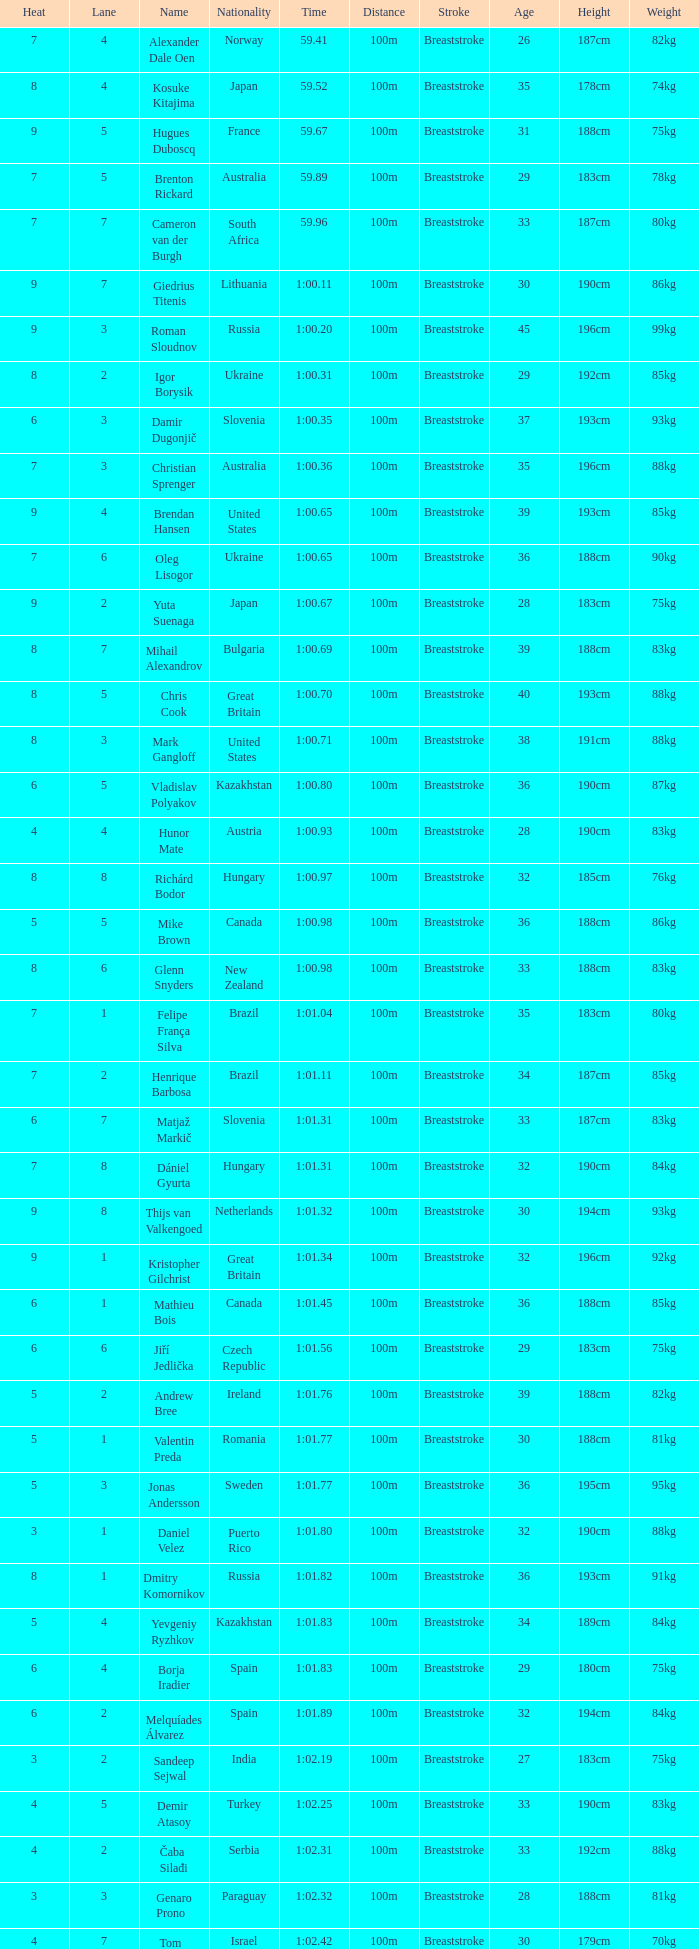Would you mind parsing the complete table? {'header': ['Heat', 'Lane', 'Name', 'Nationality', 'Time', 'Distance', 'Stroke', 'Age', 'Height', 'Weight'], 'rows': [['7', '4', 'Alexander Dale Oen', 'Norway', '59.41', '100m', 'Breaststroke', '26', '187cm', '82kg'], ['8', '4', 'Kosuke Kitajima', 'Japan', '59.52', '100m', 'Breaststroke', '35', '178cm', '74kg'], ['9', '5', 'Hugues Duboscq', 'France', '59.67', '100m', 'Breaststroke', '31', '188cm', '75kg'], ['7', '5', 'Brenton Rickard', 'Australia', '59.89', '100m', 'Breaststroke', '29', '183cm', '78kg'], ['7', '7', 'Cameron van der Burgh', 'South Africa', '59.96', '100m', 'Breaststroke', '33', '187cm', '80kg'], ['9', '7', 'Giedrius Titenis', 'Lithuania', '1:00.11', '100m', 'Breaststroke', '30', '190cm', '86kg'], ['9', '3', 'Roman Sloudnov', 'Russia', '1:00.20', '100m', 'Breaststroke', '45', '196cm', '99kg'], ['8', '2', 'Igor Borysik', 'Ukraine', '1:00.31', '100m', 'Breaststroke', '29', '192cm', '85kg'], ['6', '3', 'Damir Dugonjič', 'Slovenia', '1:00.35', '100m', 'Breaststroke', '37', '193cm', '93kg'], ['7', '3', 'Christian Sprenger', 'Australia', '1:00.36', '100m', 'Breaststroke', '35', '196cm', '88kg'], ['9', '4', 'Brendan Hansen', 'United States', '1:00.65', '100m', 'Breaststroke', '39', '193cm', '85kg'], ['7', '6', 'Oleg Lisogor', 'Ukraine', '1:00.65', '100m', 'Breaststroke', '36', '188cm', '90kg'], ['9', '2', 'Yuta Suenaga', 'Japan', '1:00.67', '100m', 'Breaststroke', '28', '183cm', '75kg'], ['8', '7', 'Mihail Alexandrov', 'Bulgaria', '1:00.69', '100m', 'Breaststroke', '39', '188cm', '83kg'], ['8', '5', 'Chris Cook', 'Great Britain', '1:00.70', '100m', 'Breaststroke', '40', '193cm', '88kg'], ['8', '3', 'Mark Gangloff', 'United States', '1:00.71', '100m', 'Breaststroke', '38', '191cm', '88kg'], ['6', '5', 'Vladislav Polyakov', 'Kazakhstan', '1:00.80', '100m', 'Breaststroke', '36', '190cm', '87kg'], ['4', '4', 'Hunor Mate', 'Austria', '1:00.93', '100m', 'Breaststroke', '28', '190cm', '83kg'], ['8', '8', 'Richárd Bodor', 'Hungary', '1:00.97', '100m', 'Breaststroke', '32', '185cm', '76kg'], ['5', '5', 'Mike Brown', 'Canada', '1:00.98', '100m', 'Breaststroke', '36', '188cm', '86kg'], ['8', '6', 'Glenn Snyders', 'New Zealand', '1:00.98', '100m', 'Breaststroke', '33', '188cm', '83kg'], ['7', '1', 'Felipe França Silva', 'Brazil', '1:01.04', '100m', 'Breaststroke', '35', '183cm', '80kg'], ['7', '2', 'Henrique Barbosa', 'Brazil', '1:01.11', '100m', 'Breaststroke', '34', '187cm', '85kg'], ['6', '7', 'Matjaž Markič', 'Slovenia', '1:01.31', '100m', 'Breaststroke', '33', '187cm', '83kg'], ['7', '8', 'Dániel Gyurta', 'Hungary', '1:01.31', '100m', 'Breaststroke', '32', '190cm', '84kg'], ['9', '8', 'Thijs van Valkengoed', 'Netherlands', '1:01.32', '100m', 'Breaststroke', '30', '194cm', '93kg'], ['9', '1', 'Kristopher Gilchrist', 'Great Britain', '1:01.34', '100m', 'Breaststroke', '32', '196cm', '92kg'], ['6', '1', 'Mathieu Bois', 'Canada', '1:01.45', '100m', 'Breaststroke', '36', '188cm', '85kg'], ['6', '6', 'Jiří Jedlička', 'Czech Republic', '1:01.56', '100m', 'Breaststroke', '29', '183cm', '75kg'], ['5', '2', 'Andrew Bree', 'Ireland', '1:01.76', '100m', 'Breaststroke', '39', '188cm', '82kg'], ['5', '1', 'Valentin Preda', 'Romania', '1:01.77', '100m', 'Breaststroke', '30', '188cm', '81kg'], ['5', '3', 'Jonas Andersson', 'Sweden', '1:01.77', '100m', 'Breaststroke', '36', '195cm', '95kg'], ['3', '1', 'Daniel Velez', 'Puerto Rico', '1:01.80', '100m', 'Breaststroke', '32', '190cm', '88kg'], ['8', '1', 'Dmitry Komornikov', 'Russia', '1:01.82', '100m', 'Breaststroke', '36', '193cm', '91kg'], ['5', '4', 'Yevgeniy Ryzhkov', 'Kazakhstan', '1:01.83', '100m', 'Breaststroke', '34', '189cm', '84kg'], ['6', '4', 'Borja Iradier', 'Spain', '1:01.83', '100m', 'Breaststroke', '29', '180cm', '75kg'], ['6', '2', 'Melquíades Álvarez', 'Spain', '1:01.89', '100m', 'Breaststroke', '32', '194cm', '84kg'], ['3', '2', 'Sandeep Sejwal', 'India', '1:02.19', '100m', 'Breaststroke', '27', '183cm', '75kg'], ['4', '5', 'Demir Atasoy', 'Turkey', '1:02.25', '100m', 'Breaststroke', '33', '190cm', '83kg'], ['4', '2', 'Čaba Silađi', 'Serbia', '1:02.31', '100m', 'Breaststroke', '33', '192cm', '88kg'], ['3', '3', 'Genaro Prono', 'Paraguay', '1:02.32', '100m', 'Breaststroke', '28', '188cm', '81kg'], ['4', '7', "Tom Be'eri", 'Israel', '1:02.42', '100m', 'Breaststroke', '30', '179cm', '70kg'], ['5', '6', 'Vanja Rogulj', 'Croatia', '1:02.42', '100m', 'Breaststroke', '35', '192cm', '85kg'], ['5', '7', 'Sofiane Daid', 'Algeria', '1:02.45', '100m', 'Breaststroke', '27', '187cm', '84kg'], ['4', '6', 'Martti Aljand', 'Estonia', '1:02.46', '100m', 'Breaststroke', '35', '190cm', '82kg'], ['4', '8', 'Xue Ruipeng', 'China', '1:02.48', '100m', 'Breaststroke', '28', '186cm', '78kg'], ['4', '3', 'Jakob Jóhann Sveinsson', 'Iceland', '1:02.50', '100m', 'Breaststroke', '32', '190cm', '88kg'], ['3', '6', 'Malick Fall', 'Senegal', '1:02.51', '100m', 'Breaststroke', '28', '187cm', '83kg'], ['5', '8', 'Viktar Vabishchevich', 'Belarus', '1:03.29', '100m', 'Breaststroke', '30', '193cm', '90kg'], ['9', '6', 'Romanos Alyfantis', 'Greece', '1:03.39', '100m', 'Breaststroke', '32', '184cm', '80kg'], ['3', '5', 'Alwin de Prins', 'Luxembourg', '1:03.64', '100m', 'Breaststroke', '27', '191cm', '87kg'], ['3', '4', 'Sergio Andres Ferreyra', 'Argentina', '1:03.65', '100m', 'Breaststroke', '29', '186cm', '85kg'], ['2', '3', 'Edgar Crespo', 'Panama', '1:03.72', '100m', 'Breaststroke', '31', '182cm', '78kg'], ['2', '4', 'Sergiu Postica', 'Moldova', '1:03.83', '100m', 'Breaststroke', '29', '191cm', '86kg'], ['3', '8', 'Andrei Cross', 'Barbados', '1:04.57', '100m', 'Breaststroke', '33', '180cm', '73kg'], ['3', '7', 'Ivan Demyanenko', 'Uzbekistan', '1:05.14', '100m', 'Breaststroke', '30', '180cm', '75kg'], ['2', '6', 'Wael Koubrousli', 'Lebanon', '1:06.22', '100m', 'Breaststroke', '27', '168cm', '64kg'], ['2', '5', 'Nguyen Huu Viet', 'Vietnam', '1:06.36', '100m', 'Breaststroke', '29', '165cm', '55kg'], ['2', '2', 'Erik Rajohnson', 'Madagascar', '1:08.42', '100m', 'Breaststroke', '24', '175cm', '70kg'], ['2', '7', 'Boldbaataryn Bütekh-Uils', 'Mongolia', '1:10.80', '100m', 'Breaststroke', '23', '185cm', '89kg'], ['1', '4', 'Osama Mohammed Ye Alarag', 'Qatar', '1:10.83', '100m', 'Breaststroke', '19', '175cm', '70kg'], ['1', '5', 'Mohammed Al-Habsi', 'Oman', '1:12.28', '100m', 'Breaststroke', '22', '180cm', '79kg'], ['1', '3', 'Petero Okotai', 'Cook Islands', '1:20.20', '100m', 'Breaststroke', '18', '172cm', '65kg'], ['6', '8', 'Alessandro Terrin', 'Italy', 'DSQ', '100m', 'Breaststroke', '27', '191cm', '93kg'], ['4', '1', 'Mohammad Alirezaei', 'Iran', 'DNS', '100m', 'Breaststroke', '36', '192cm', '91kg']]} What is the smallest lane number of Xue Ruipeng? 8.0. 